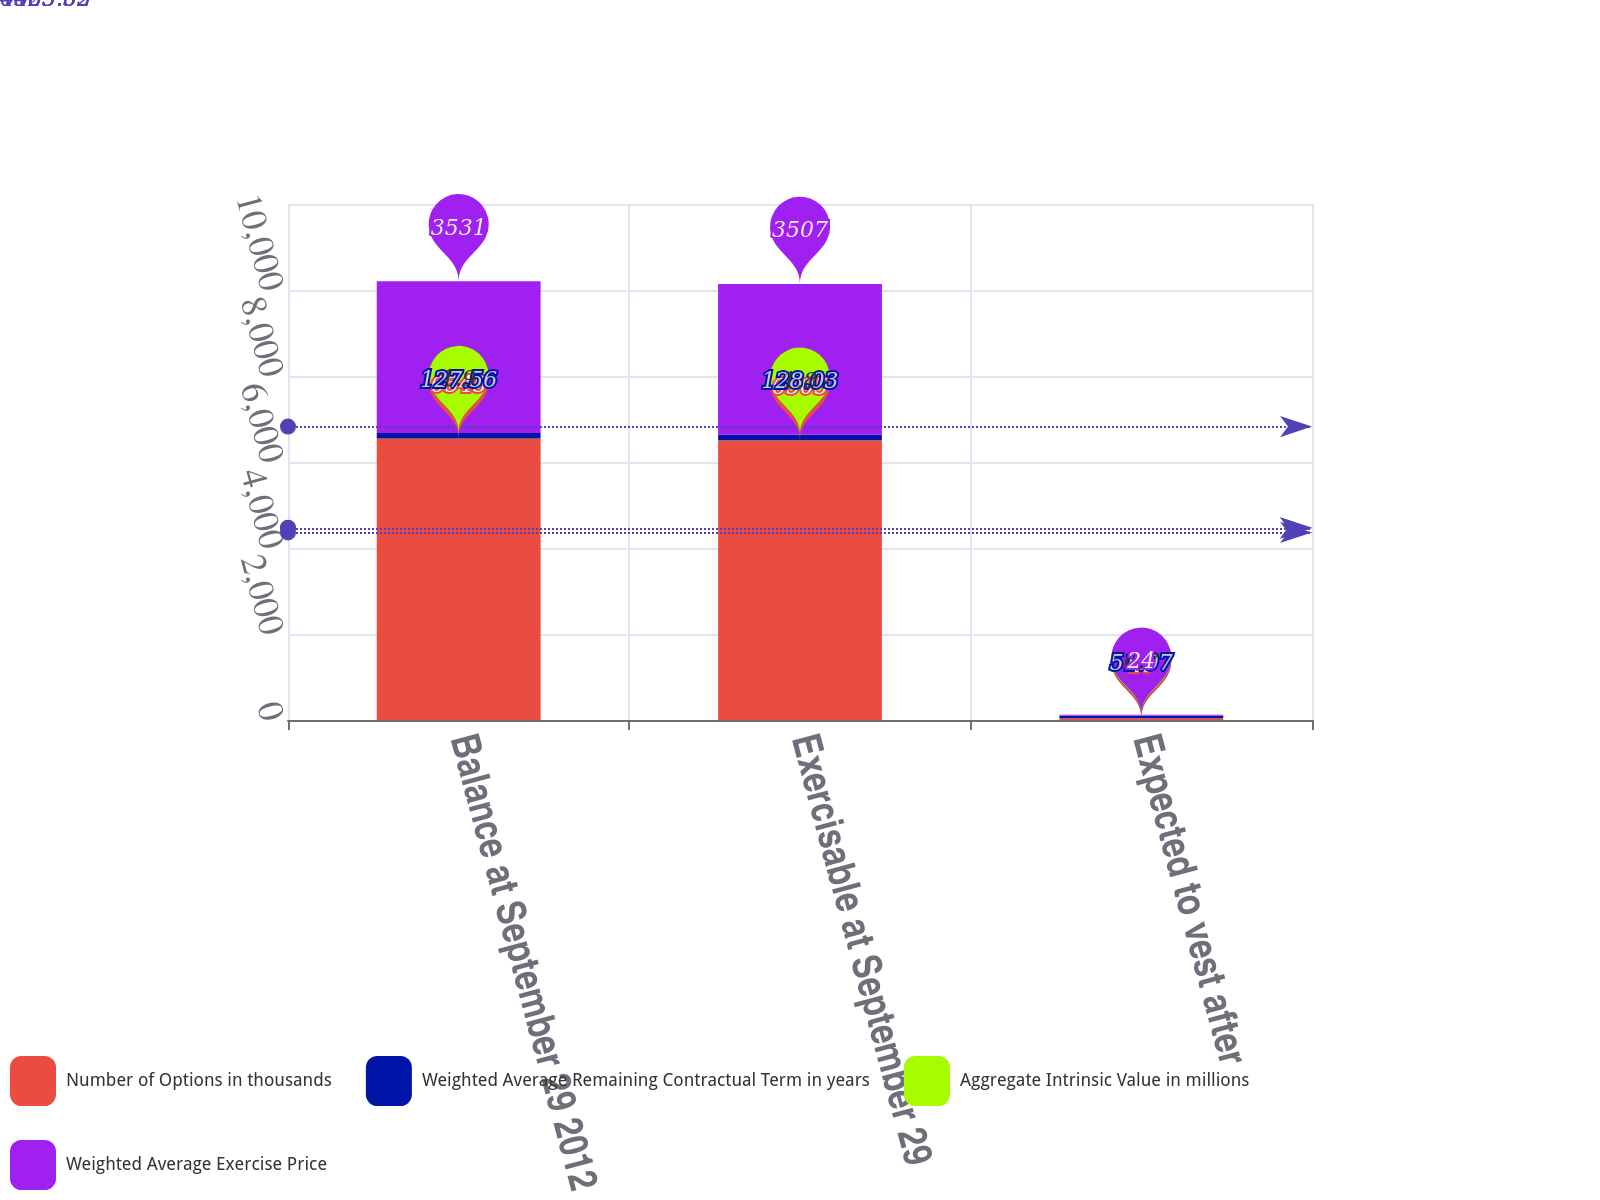Convert chart to OTSL. <chart><loc_0><loc_0><loc_500><loc_500><stacked_bar_chart><ecel><fcel>Balance at September 29 2012<fcel>Exercisable at September 29<fcel>Expected to vest after<nl><fcel>Number of Options in thousands<fcel>6545<fcel>6505<fcel>40<nl><fcel>Weighted Average Remaining Contractual Term in years<fcel>127.56<fcel>128.03<fcel>51.07<nl><fcel>Aggregate Intrinsic Value in millions<fcel>1.9<fcel>1.8<fcel>6.7<nl><fcel>Weighted Average Exercise Price<fcel>3531<fcel>3507<fcel>24<nl></chart> 